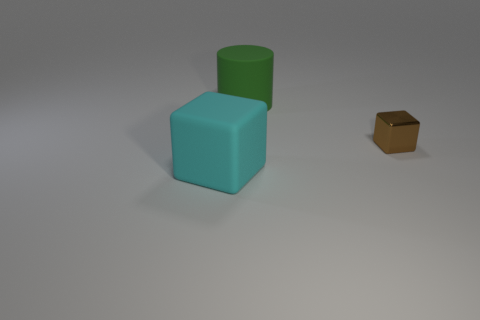Add 3 blue matte blocks. How many objects exist? 6 Subtract all blocks. How many objects are left? 1 Subtract all small green balls. Subtract all cubes. How many objects are left? 1 Add 2 small cubes. How many small cubes are left? 3 Add 2 large yellow rubber objects. How many large yellow rubber objects exist? 2 Subtract 0 purple cylinders. How many objects are left? 3 